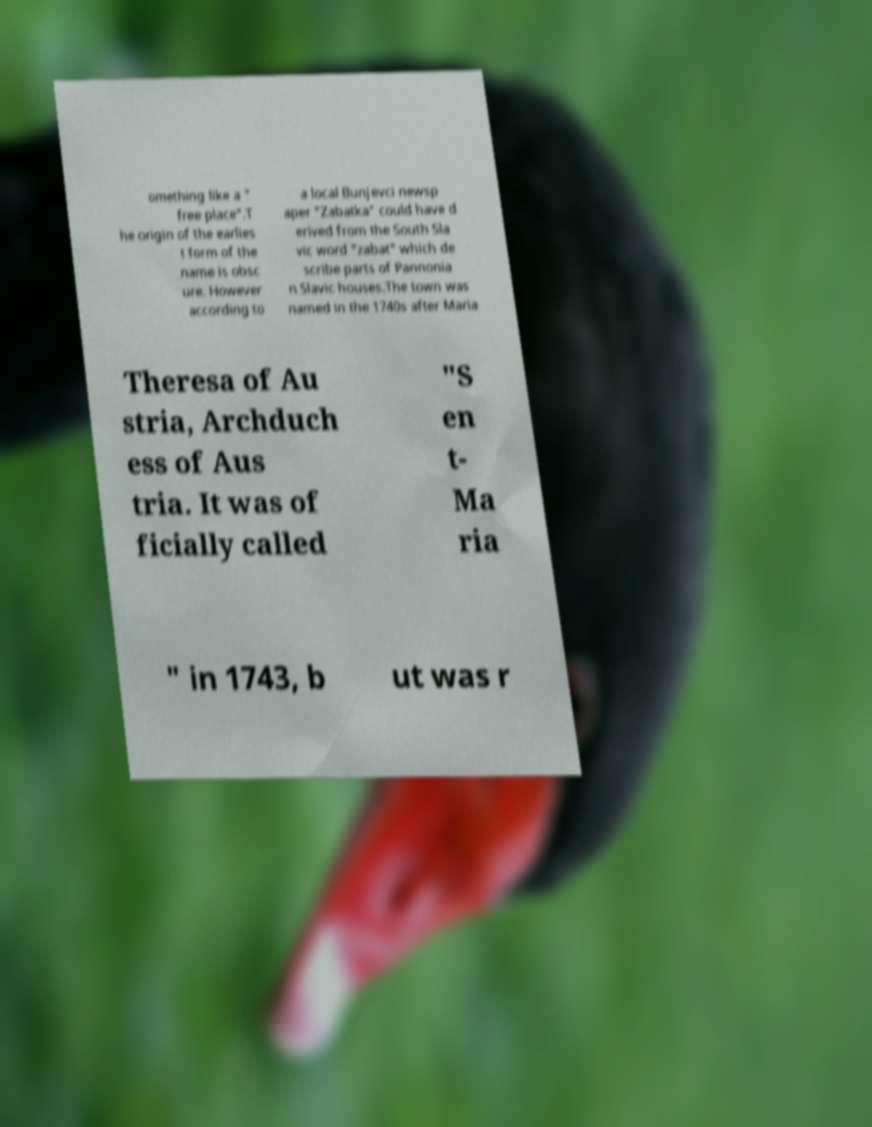Can you accurately transcribe the text from the provided image for me? omething like a " free place".T he origin of the earlies t form of the name is obsc ure. However according to a local Bunjevci newsp aper "Zabatka" could have d erived from the South Sla vic word "zabat" which de scribe parts of Pannonia n Slavic houses.The town was named in the 1740s after Maria Theresa of Au stria, Archduch ess of Aus tria. It was of ficially called "S en t- Ma ria " in 1743, b ut was r 